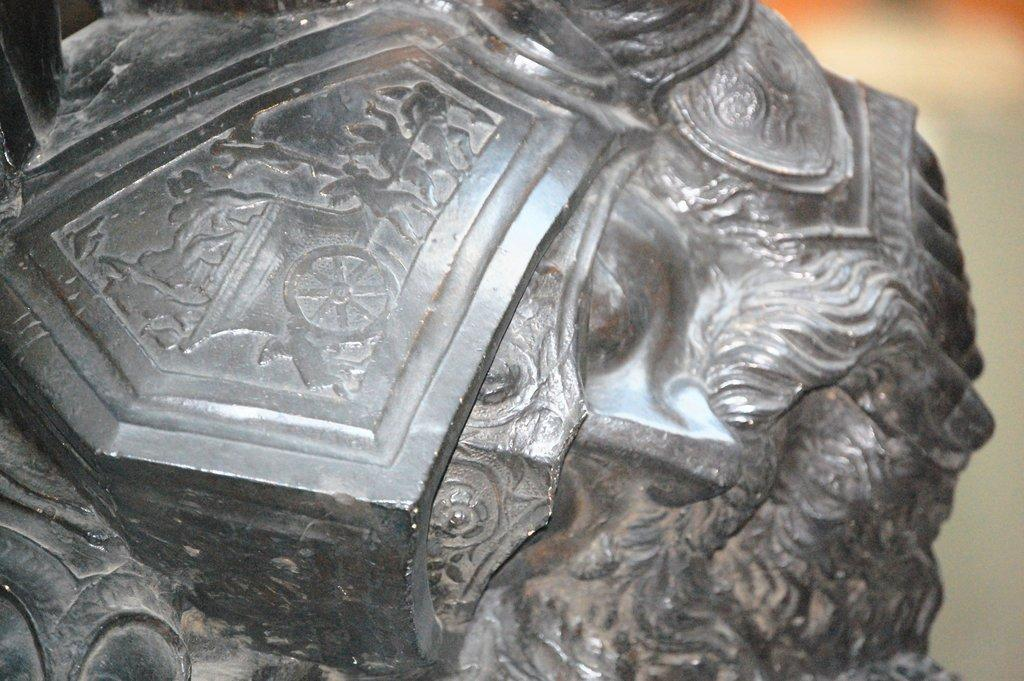What is the main subject of the image? There is a sculpture in the image. How many chickens are standing on the sculpture's feet in the image? There are no chickens or feet present in the image; it features a sculpture. 